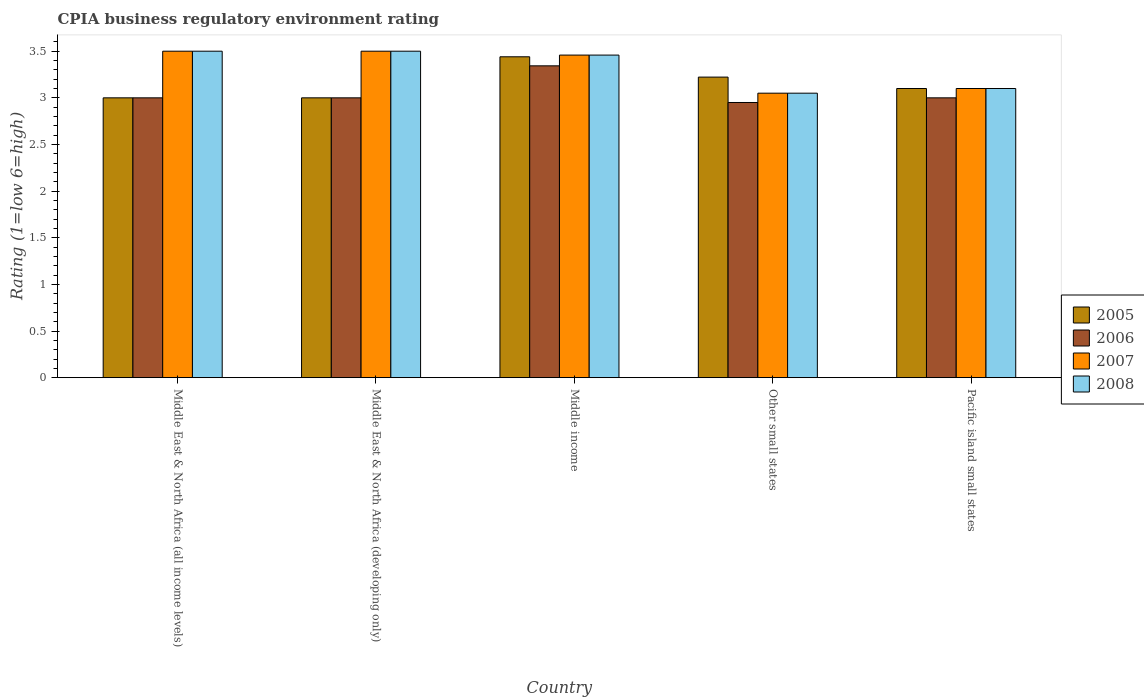How many groups of bars are there?
Your response must be concise. 5. Are the number of bars on each tick of the X-axis equal?
Offer a terse response. Yes. How many bars are there on the 5th tick from the left?
Your answer should be compact. 4. How many bars are there on the 5th tick from the right?
Offer a terse response. 4. In how many cases, is the number of bars for a given country not equal to the number of legend labels?
Ensure brevity in your answer.  0. What is the CPIA rating in 2006 in Other small states?
Offer a very short reply. 2.95. Across all countries, what is the maximum CPIA rating in 2007?
Provide a succinct answer. 3.5. Across all countries, what is the minimum CPIA rating in 2006?
Your response must be concise. 2.95. In which country was the CPIA rating in 2007 maximum?
Keep it short and to the point. Middle East & North Africa (all income levels). In which country was the CPIA rating in 2008 minimum?
Offer a very short reply. Other small states. What is the total CPIA rating in 2005 in the graph?
Provide a short and direct response. 15.76. What is the average CPIA rating in 2008 per country?
Keep it short and to the point. 3.32. What is the difference between the CPIA rating of/in 2007 and CPIA rating of/in 2005 in Other small states?
Keep it short and to the point. -0.17. What is the ratio of the CPIA rating in 2007 in Middle income to that in Pacific island small states?
Give a very brief answer. 1.12. Is the CPIA rating in 2008 in Middle East & North Africa (developing only) less than that in Other small states?
Your answer should be compact. No. What is the difference between the highest and the second highest CPIA rating in 2007?
Keep it short and to the point. -0.04. What is the difference between the highest and the lowest CPIA rating in 2006?
Keep it short and to the point. 0.39. In how many countries, is the CPIA rating in 2005 greater than the average CPIA rating in 2005 taken over all countries?
Your answer should be very brief. 2. Is the sum of the CPIA rating in 2005 in Middle East & North Africa (developing only) and Middle income greater than the maximum CPIA rating in 2008 across all countries?
Keep it short and to the point. Yes. What does the 1st bar from the right in Middle East & North Africa (developing only) represents?
Give a very brief answer. 2008. Is it the case that in every country, the sum of the CPIA rating in 2006 and CPIA rating in 2005 is greater than the CPIA rating in 2007?
Provide a short and direct response. Yes. Are all the bars in the graph horizontal?
Offer a very short reply. No. How many countries are there in the graph?
Offer a very short reply. 5. What is the difference between two consecutive major ticks on the Y-axis?
Ensure brevity in your answer.  0.5. Are the values on the major ticks of Y-axis written in scientific E-notation?
Offer a very short reply. No. Does the graph contain any zero values?
Make the answer very short. No. Does the graph contain grids?
Give a very brief answer. No. Where does the legend appear in the graph?
Provide a short and direct response. Center right. What is the title of the graph?
Give a very brief answer. CPIA business regulatory environment rating. Does "2000" appear as one of the legend labels in the graph?
Offer a terse response. No. What is the Rating (1=low 6=high) in 2005 in Middle East & North Africa (all income levels)?
Make the answer very short. 3. What is the Rating (1=low 6=high) of 2006 in Middle East & North Africa (all income levels)?
Ensure brevity in your answer.  3. What is the Rating (1=low 6=high) of 2007 in Middle East & North Africa (all income levels)?
Offer a very short reply. 3.5. What is the Rating (1=low 6=high) of 2005 in Middle East & North Africa (developing only)?
Provide a succinct answer. 3. What is the Rating (1=low 6=high) of 2006 in Middle East & North Africa (developing only)?
Provide a succinct answer. 3. What is the Rating (1=low 6=high) of 2005 in Middle income?
Offer a terse response. 3.44. What is the Rating (1=low 6=high) of 2006 in Middle income?
Provide a short and direct response. 3.34. What is the Rating (1=low 6=high) in 2007 in Middle income?
Provide a succinct answer. 3.46. What is the Rating (1=low 6=high) in 2008 in Middle income?
Give a very brief answer. 3.46. What is the Rating (1=low 6=high) in 2005 in Other small states?
Your answer should be very brief. 3.22. What is the Rating (1=low 6=high) in 2006 in Other small states?
Give a very brief answer. 2.95. What is the Rating (1=low 6=high) in 2007 in Other small states?
Your answer should be very brief. 3.05. What is the Rating (1=low 6=high) of 2008 in Other small states?
Ensure brevity in your answer.  3.05. What is the Rating (1=low 6=high) of 2005 in Pacific island small states?
Your answer should be very brief. 3.1. What is the Rating (1=low 6=high) of 2008 in Pacific island small states?
Give a very brief answer. 3.1. Across all countries, what is the maximum Rating (1=low 6=high) of 2005?
Give a very brief answer. 3.44. Across all countries, what is the maximum Rating (1=low 6=high) of 2006?
Provide a short and direct response. 3.34. Across all countries, what is the minimum Rating (1=low 6=high) in 2005?
Your response must be concise. 3. Across all countries, what is the minimum Rating (1=low 6=high) of 2006?
Provide a succinct answer. 2.95. Across all countries, what is the minimum Rating (1=low 6=high) in 2007?
Ensure brevity in your answer.  3.05. Across all countries, what is the minimum Rating (1=low 6=high) in 2008?
Your response must be concise. 3.05. What is the total Rating (1=low 6=high) in 2005 in the graph?
Keep it short and to the point. 15.76. What is the total Rating (1=low 6=high) in 2006 in the graph?
Your response must be concise. 15.29. What is the total Rating (1=low 6=high) of 2007 in the graph?
Make the answer very short. 16.61. What is the total Rating (1=low 6=high) of 2008 in the graph?
Ensure brevity in your answer.  16.61. What is the difference between the Rating (1=low 6=high) of 2005 in Middle East & North Africa (all income levels) and that in Middle East & North Africa (developing only)?
Make the answer very short. 0. What is the difference between the Rating (1=low 6=high) of 2008 in Middle East & North Africa (all income levels) and that in Middle East & North Africa (developing only)?
Your answer should be very brief. 0. What is the difference between the Rating (1=low 6=high) in 2005 in Middle East & North Africa (all income levels) and that in Middle income?
Make the answer very short. -0.44. What is the difference between the Rating (1=low 6=high) in 2006 in Middle East & North Africa (all income levels) and that in Middle income?
Give a very brief answer. -0.34. What is the difference between the Rating (1=low 6=high) of 2007 in Middle East & North Africa (all income levels) and that in Middle income?
Make the answer very short. 0.04. What is the difference between the Rating (1=low 6=high) of 2008 in Middle East & North Africa (all income levels) and that in Middle income?
Provide a short and direct response. 0.04. What is the difference between the Rating (1=low 6=high) in 2005 in Middle East & North Africa (all income levels) and that in Other small states?
Give a very brief answer. -0.22. What is the difference between the Rating (1=low 6=high) of 2006 in Middle East & North Africa (all income levels) and that in Other small states?
Keep it short and to the point. 0.05. What is the difference between the Rating (1=low 6=high) in 2007 in Middle East & North Africa (all income levels) and that in Other small states?
Your answer should be very brief. 0.45. What is the difference between the Rating (1=low 6=high) of 2008 in Middle East & North Africa (all income levels) and that in Other small states?
Keep it short and to the point. 0.45. What is the difference between the Rating (1=low 6=high) of 2008 in Middle East & North Africa (all income levels) and that in Pacific island small states?
Make the answer very short. 0.4. What is the difference between the Rating (1=low 6=high) in 2005 in Middle East & North Africa (developing only) and that in Middle income?
Make the answer very short. -0.44. What is the difference between the Rating (1=low 6=high) in 2006 in Middle East & North Africa (developing only) and that in Middle income?
Provide a succinct answer. -0.34. What is the difference between the Rating (1=low 6=high) in 2007 in Middle East & North Africa (developing only) and that in Middle income?
Ensure brevity in your answer.  0.04. What is the difference between the Rating (1=low 6=high) in 2008 in Middle East & North Africa (developing only) and that in Middle income?
Ensure brevity in your answer.  0.04. What is the difference between the Rating (1=low 6=high) of 2005 in Middle East & North Africa (developing only) and that in Other small states?
Give a very brief answer. -0.22. What is the difference between the Rating (1=low 6=high) of 2007 in Middle East & North Africa (developing only) and that in Other small states?
Ensure brevity in your answer.  0.45. What is the difference between the Rating (1=low 6=high) in 2008 in Middle East & North Africa (developing only) and that in Other small states?
Your response must be concise. 0.45. What is the difference between the Rating (1=low 6=high) of 2005 in Middle East & North Africa (developing only) and that in Pacific island small states?
Your answer should be very brief. -0.1. What is the difference between the Rating (1=low 6=high) in 2006 in Middle East & North Africa (developing only) and that in Pacific island small states?
Give a very brief answer. 0. What is the difference between the Rating (1=low 6=high) of 2008 in Middle East & North Africa (developing only) and that in Pacific island small states?
Offer a terse response. 0.4. What is the difference between the Rating (1=low 6=high) in 2005 in Middle income and that in Other small states?
Keep it short and to the point. 0.22. What is the difference between the Rating (1=low 6=high) in 2006 in Middle income and that in Other small states?
Provide a short and direct response. 0.39. What is the difference between the Rating (1=low 6=high) in 2007 in Middle income and that in Other small states?
Ensure brevity in your answer.  0.41. What is the difference between the Rating (1=low 6=high) of 2008 in Middle income and that in Other small states?
Keep it short and to the point. 0.41. What is the difference between the Rating (1=low 6=high) of 2005 in Middle income and that in Pacific island small states?
Your response must be concise. 0.34. What is the difference between the Rating (1=low 6=high) in 2006 in Middle income and that in Pacific island small states?
Make the answer very short. 0.34. What is the difference between the Rating (1=low 6=high) of 2007 in Middle income and that in Pacific island small states?
Keep it short and to the point. 0.36. What is the difference between the Rating (1=low 6=high) of 2008 in Middle income and that in Pacific island small states?
Provide a short and direct response. 0.36. What is the difference between the Rating (1=low 6=high) of 2005 in Other small states and that in Pacific island small states?
Your answer should be compact. 0.12. What is the difference between the Rating (1=low 6=high) in 2006 in Other small states and that in Pacific island small states?
Provide a succinct answer. -0.05. What is the difference between the Rating (1=low 6=high) of 2007 in Other small states and that in Pacific island small states?
Provide a short and direct response. -0.05. What is the difference between the Rating (1=low 6=high) in 2008 in Other small states and that in Pacific island small states?
Your answer should be very brief. -0.05. What is the difference between the Rating (1=low 6=high) in 2005 in Middle East & North Africa (all income levels) and the Rating (1=low 6=high) in 2008 in Middle East & North Africa (developing only)?
Provide a succinct answer. -0.5. What is the difference between the Rating (1=low 6=high) in 2006 in Middle East & North Africa (all income levels) and the Rating (1=low 6=high) in 2007 in Middle East & North Africa (developing only)?
Make the answer very short. -0.5. What is the difference between the Rating (1=low 6=high) in 2007 in Middle East & North Africa (all income levels) and the Rating (1=low 6=high) in 2008 in Middle East & North Africa (developing only)?
Give a very brief answer. 0. What is the difference between the Rating (1=low 6=high) in 2005 in Middle East & North Africa (all income levels) and the Rating (1=low 6=high) in 2006 in Middle income?
Ensure brevity in your answer.  -0.34. What is the difference between the Rating (1=low 6=high) in 2005 in Middle East & North Africa (all income levels) and the Rating (1=low 6=high) in 2007 in Middle income?
Provide a succinct answer. -0.46. What is the difference between the Rating (1=low 6=high) in 2005 in Middle East & North Africa (all income levels) and the Rating (1=low 6=high) in 2008 in Middle income?
Make the answer very short. -0.46. What is the difference between the Rating (1=low 6=high) in 2006 in Middle East & North Africa (all income levels) and the Rating (1=low 6=high) in 2007 in Middle income?
Make the answer very short. -0.46. What is the difference between the Rating (1=low 6=high) in 2006 in Middle East & North Africa (all income levels) and the Rating (1=low 6=high) in 2008 in Middle income?
Give a very brief answer. -0.46. What is the difference between the Rating (1=low 6=high) in 2007 in Middle East & North Africa (all income levels) and the Rating (1=low 6=high) in 2008 in Middle income?
Ensure brevity in your answer.  0.04. What is the difference between the Rating (1=low 6=high) in 2005 in Middle East & North Africa (all income levels) and the Rating (1=low 6=high) in 2007 in Other small states?
Your answer should be compact. -0.05. What is the difference between the Rating (1=low 6=high) in 2006 in Middle East & North Africa (all income levels) and the Rating (1=low 6=high) in 2007 in Other small states?
Offer a very short reply. -0.05. What is the difference between the Rating (1=low 6=high) in 2007 in Middle East & North Africa (all income levels) and the Rating (1=low 6=high) in 2008 in Other small states?
Provide a short and direct response. 0.45. What is the difference between the Rating (1=low 6=high) of 2005 in Middle East & North Africa (all income levels) and the Rating (1=low 6=high) of 2006 in Pacific island small states?
Your answer should be very brief. 0. What is the difference between the Rating (1=low 6=high) in 2005 in Middle East & North Africa (all income levels) and the Rating (1=low 6=high) in 2007 in Pacific island small states?
Give a very brief answer. -0.1. What is the difference between the Rating (1=low 6=high) in 2006 in Middle East & North Africa (all income levels) and the Rating (1=low 6=high) in 2008 in Pacific island small states?
Your response must be concise. -0.1. What is the difference between the Rating (1=low 6=high) of 2005 in Middle East & North Africa (developing only) and the Rating (1=low 6=high) of 2006 in Middle income?
Offer a very short reply. -0.34. What is the difference between the Rating (1=low 6=high) in 2005 in Middle East & North Africa (developing only) and the Rating (1=low 6=high) in 2007 in Middle income?
Keep it short and to the point. -0.46. What is the difference between the Rating (1=low 6=high) in 2005 in Middle East & North Africa (developing only) and the Rating (1=low 6=high) in 2008 in Middle income?
Your response must be concise. -0.46. What is the difference between the Rating (1=low 6=high) of 2006 in Middle East & North Africa (developing only) and the Rating (1=low 6=high) of 2007 in Middle income?
Your response must be concise. -0.46. What is the difference between the Rating (1=low 6=high) of 2006 in Middle East & North Africa (developing only) and the Rating (1=low 6=high) of 2008 in Middle income?
Your response must be concise. -0.46. What is the difference between the Rating (1=low 6=high) in 2007 in Middle East & North Africa (developing only) and the Rating (1=low 6=high) in 2008 in Middle income?
Keep it short and to the point. 0.04. What is the difference between the Rating (1=low 6=high) in 2005 in Middle East & North Africa (developing only) and the Rating (1=low 6=high) in 2007 in Other small states?
Offer a very short reply. -0.05. What is the difference between the Rating (1=low 6=high) in 2007 in Middle East & North Africa (developing only) and the Rating (1=low 6=high) in 2008 in Other small states?
Make the answer very short. 0.45. What is the difference between the Rating (1=low 6=high) of 2006 in Middle East & North Africa (developing only) and the Rating (1=low 6=high) of 2008 in Pacific island small states?
Offer a terse response. -0.1. What is the difference between the Rating (1=low 6=high) in 2005 in Middle income and the Rating (1=low 6=high) in 2006 in Other small states?
Offer a terse response. 0.49. What is the difference between the Rating (1=low 6=high) of 2005 in Middle income and the Rating (1=low 6=high) of 2007 in Other small states?
Give a very brief answer. 0.39. What is the difference between the Rating (1=low 6=high) in 2005 in Middle income and the Rating (1=low 6=high) in 2008 in Other small states?
Offer a very short reply. 0.39. What is the difference between the Rating (1=low 6=high) in 2006 in Middle income and the Rating (1=low 6=high) in 2007 in Other small states?
Your answer should be very brief. 0.29. What is the difference between the Rating (1=low 6=high) of 2006 in Middle income and the Rating (1=low 6=high) of 2008 in Other small states?
Keep it short and to the point. 0.29. What is the difference between the Rating (1=low 6=high) of 2007 in Middle income and the Rating (1=low 6=high) of 2008 in Other small states?
Your response must be concise. 0.41. What is the difference between the Rating (1=low 6=high) in 2005 in Middle income and the Rating (1=low 6=high) in 2006 in Pacific island small states?
Offer a terse response. 0.44. What is the difference between the Rating (1=low 6=high) in 2005 in Middle income and the Rating (1=low 6=high) in 2007 in Pacific island small states?
Provide a short and direct response. 0.34. What is the difference between the Rating (1=low 6=high) in 2005 in Middle income and the Rating (1=low 6=high) in 2008 in Pacific island small states?
Ensure brevity in your answer.  0.34. What is the difference between the Rating (1=low 6=high) in 2006 in Middle income and the Rating (1=low 6=high) in 2007 in Pacific island small states?
Your answer should be very brief. 0.24. What is the difference between the Rating (1=low 6=high) in 2006 in Middle income and the Rating (1=low 6=high) in 2008 in Pacific island small states?
Ensure brevity in your answer.  0.24. What is the difference between the Rating (1=low 6=high) of 2007 in Middle income and the Rating (1=low 6=high) of 2008 in Pacific island small states?
Your answer should be compact. 0.36. What is the difference between the Rating (1=low 6=high) of 2005 in Other small states and the Rating (1=low 6=high) of 2006 in Pacific island small states?
Give a very brief answer. 0.22. What is the difference between the Rating (1=low 6=high) in 2005 in Other small states and the Rating (1=low 6=high) in 2007 in Pacific island small states?
Ensure brevity in your answer.  0.12. What is the difference between the Rating (1=low 6=high) of 2005 in Other small states and the Rating (1=low 6=high) of 2008 in Pacific island small states?
Provide a short and direct response. 0.12. What is the difference between the Rating (1=low 6=high) of 2006 in Other small states and the Rating (1=low 6=high) of 2008 in Pacific island small states?
Offer a very short reply. -0.15. What is the average Rating (1=low 6=high) of 2005 per country?
Your answer should be very brief. 3.15. What is the average Rating (1=low 6=high) of 2006 per country?
Your response must be concise. 3.06. What is the average Rating (1=low 6=high) in 2007 per country?
Give a very brief answer. 3.32. What is the average Rating (1=low 6=high) in 2008 per country?
Keep it short and to the point. 3.32. What is the difference between the Rating (1=low 6=high) of 2005 and Rating (1=low 6=high) of 2008 in Middle East & North Africa (all income levels)?
Your answer should be very brief. -0.5. What is the difference between the Rating (1=low 6=high) of 2006 and Rating (1=low 6=high) of 2007 in Middle East & North Africa (all income levels)?
Provide a succinct answer. -0.5. What is the difference between the Rating (1=low 6=high) of 2006 and Rating (1=low 6=high) of 2008 in Middle East & North Africa (all income levels)?
Keep it short and to the point. -0.5. What is the difference between the Rating (1=low 6=high) of 2005 and Rating (1=low 6=high) of 2006 in Middle East & North Africa (developing only)?
Your answer should be very brief. 0. What is the difference between the Rating (1=low 6=high) in 2005 and Rating (1=low 6=high) in 2008 in Middle East & North Africa (developing only)?
Ensure brevity in your answer.  -0.5. What is the difference between the Rating (1=low 6=high) in 2006 and Rating (1=low 6=high) in 2007 in Middle East & North Africa (developing only)?
Offer a terse response. -0.5. What is the difference between the Rating (1=low 6=high) in 2005 and Rating (1=low 6=high) in 2006 in Middle income?
Your answer should be compact. 0.1. What is the difference between the Rating (1=low 6=high) of 2005 and Rating (1=low 6=high) of 2007 in Middle income?
Offer a terse response. -0.02. What is the difference between the Rating (1=low 6=high) of 2005 and Rating (1=low 6=high) of 2008 in Middle income?
Provide a succinct answer. -0.02. What is the difference between the Rating (1=low 6=high) in 2006 and Rating (1=low 6=high) in 2007 in Middle income?
Keep it short and to the point. -0.12. What is the difference between the Rating (1=low 6=high) of 2006 and Rating (1=low 6=high) of 2008 in Middle income?
Offer a terse response. -0.12. What is the difference between the Rating (1=low 6=high) in 2005 and Rating (1=low 6=high) in 2006 in Other small states?
Offer a terse response. 0.27. What is the difference between the Rating (1=low 6=high) in 2005 and Rating (1=low 6=high) in 2007 in Other small states?
Keep it short and to the point. 0.17. What is the difference between the Rating (1=low 6=high) of 2005 and Rating (1=low 6=high) of 2008 in Other small states?
Offer a very short reply. 0.17. What is the difference between the Rating (1=low 6=high) of 2006 and Rating (1=low 6=high) of 2007 in Other small states?
Offer a terse response. -0.1. What is the difference between the Rating (1=low 6=high) of 2006 and Rating (1=low 6=high) of 2008 in Other small states?
Provide a succinct answer. -0.1. What is the difference between the Rating (1=low 6=high) in 2005 and Rating (1=low 6=high) in 2007 in Pacific island small states?
Your answer should be compact. 0. What is the difference between the Rating (1=low 6=high) of 2005 and Rating (1=low 6=high) of 2008 in Pacific island small states?
Your response must be concise. 0. What is the difference between the Rating (1=low 6=high) in 2006 and Rating (1=low 6=high) in 2007 in Pacific island small states?
Offer a terse response. -0.1. What is the ratio of the Rating (1=low 6=high) in 2005 in Middle East & North Africa (all income levels) to that in Middle East & North Africa (developing only)?
Your answer should be compact. 1. What is the ratio of the Rating (1=low 6=high) in 2005 in Middle East & North Africa (all income levels) to that in Middle income?
Your response must be concise. 0.87. What is the ratio of the Rating (1=low 6=high) of 2006 in Middle East & North Africa (all income levels) to that in Middle income?
Your answer should be compact. 0.9. What is the ratio of the Rating (1=low 6=high) in 2007 in Middle East & North Africa (all income levels) to that in Middle income?
Ensure brevity in your answer.  1.01. What is the ratio of the Rating (1=low 6=high) of 2008 in Middle East & North Africa (all income levels) to that in Middle income?
Your answer should be compact. 1.01. What is the ratio of the Rating (1=low 6=high) of 2006 in Middle East & North Africa (all income levels) to that in Other small states?
Ensure brevity in your answer.  1.02. What is the ratio of the Rating (1=low 6=high) in 2007 in Middle East & North Africa (all income levels) to that in Other small states?
Provide a succinct answer. 1.15. What is the ratio of the Rating (1=low 6=high) in 2008 in Middle East & North Africa (all income levels) to that in Other small states?
Your answer should be very brief. 1.15. What is the ratio of the Rating (1=low 6=high) in 2005 in Middle East & North Africa (all income levels) to that in Pacific island small states?
Ensure brevity in your answer.  0.97. What is the ratio of the Rating (1=low 6=high) of 2006 in Middle East & North Africa (all income levels) to that in Pacific island small states?
Your answer should be compact. 1. What is the ratio of the Rating (1=low 6=high) in 2007 in Middle East & North Africa (all income levels) to that in Pacific island small states?
Make the answer very short. 1.13. What is the ratio of the Rating (1=low 6=high) in 2008 in Middle East & North Africa (all income levels) to that in Pacific island small states?
Your answer should be very brief. 1.13. What is the ratio of the Rating (1=low 6=high) in 2005 in Middle East & North Africa (developing only) to that in Middle income?
Offer a very short reply. 0.87. What is the ratio of the Rating (1=low 6=high) in 2006 in Middle East & North Africa (developing only) to that in Middle income?
Provide a short and direct response. 0.9. What is the ratio of the Rating (1=low 6=high) in 2007 in Middle East & North Africa (developing only) to that in Middle income?
Provide a short and direct response. 1.01. What is the ratio of the Rating (1=low 6=high) in 2008 in Middle East & North Africa (developing only) to that in Middle income?
Offer a very short reply. 1.01. What is the ratio of the Rating (1=low 6=high) in 2005 in Middle East & North Africa (developing only) to that in Other small states?
Your answer should be very brief. 0.93. What is the ratio of the Rating (1=low 6=high) in 2006 in Middle East & North Africa (developing only) to that in Other small states?
Your response must be concise. 1.02. What is the ratio of the Rating (1=low 6=high) of 2007 in Middle East & North Africa (developing only) to that in Other small states?
Offer a very short reply. 1.15. What is the ratio of the Rating (1=low 6=high) in 2008 in Middle East & North Africa (developing only) to that in Other small states?
Your answer should be very brief. 1.15. What is the ratio of the Rating (1=low 6=high) in 2006 in Middle East & North Africa (developing only) to that in Pacific island small states?
Offer a terse response. 1. What is the ratio of the Rating (1=low 6=high) in 2007 in Middle East & North Africa (developing only) to that in Pacific island small states?
Give a very brief answer. 1.13. What is the ratio of the Rating (1=low 6=high) of 2008 in Middle East & North Africa (developing only) to that in Pacific island small states?
Your response must be concise. 1.13. What is the ratio of the Rating (1=low 6=high) of 2005 in Middle income to that in Other small states?
Your answer should be compact. 1.07. What is the ratio of the Rating (1=low 6=high) of 2006 in Middle income to that in Other small states?
Your response must be concise. 1.13. What is the ratio of the Rating (1=low 6=high) in 2007 in Middle income to that in Other small states?
Make the answer very short. 1.13. What is the ratio of the Rating (1=low 6=high) in 2008 in Middle income to that in Other small states?
Your answer should be compact. 1.13. What is the ratio of the Rating (1=low 6=high) of 2005 in Middle income to that in Pacific island small states?
Provide a succinct answer. 1.11. What is the ratio of the Rating (1=low 6=high) in 2006 in Middle income to that in Pacific island small states?
Your answer should be compact. 1.11. What is the ratio of the Rating (1=low 6=high) in 2007 in Middle income to that in Pacific island small states?
Keep it short and to the point. 1.12. What is the ratio of the Rating (1=low 6=high) of 2008 in Middle income to that in Pacific island small states?
Your response must be concise. 1.12. What is the ratio of the Rating (1=low 6=high) in 2005 in Other small states to that in Pacific island small states?
Offer a very short reply. 1.04. What is the ratio of the Rating (1=low 6=high) of 2006 in Other small states to that in Pacific island small states?
Ensure brevity in your answer.  0.98. What is the ratio of the Rating (1=low 6=high) in 2007 in Other small states to that in Pacific island small states?
Your response must be concise. 0.98. What is the ratio of the Rating (1=low 6=high) of 2008 in Other small states to that in Pacific island small states?
Keep it short and to the point. 0.98. What is the difference between the highest and the second highest Rating (1=low 6=high) in 2005?
Give a very brief answer. 0.22. What is the difference between the highest and the second highest Rating (1=low 6=high) in 2006?
Provide a short and direct response. 0.34. What is the difference between the highest and the second highest Rating (1=low 6=high) in 2007?
Offer a very short reply. 0. What is the difference between the highest and the second highest Rating (1=low 6=high) in 2008?
Your answer should be compact. 0. What is the difference between the highest and the lowest Rating (1=low 6=high) in 2005?
Provide a succinct answer. 0.44. What is the difference between the highest and the lowest Rating (1=low 6=high) of 2006?
Ensure brevity in your answer.  0.39. What is the difference between the highest and the lowest Rating (1=low 6=high) of 2007?
Provide a short and direct response. 0.45. What is the difference between the highest and the lowest Rating (1=low 6=high) of 2008?
Provide a succinct answer. 0.45. 